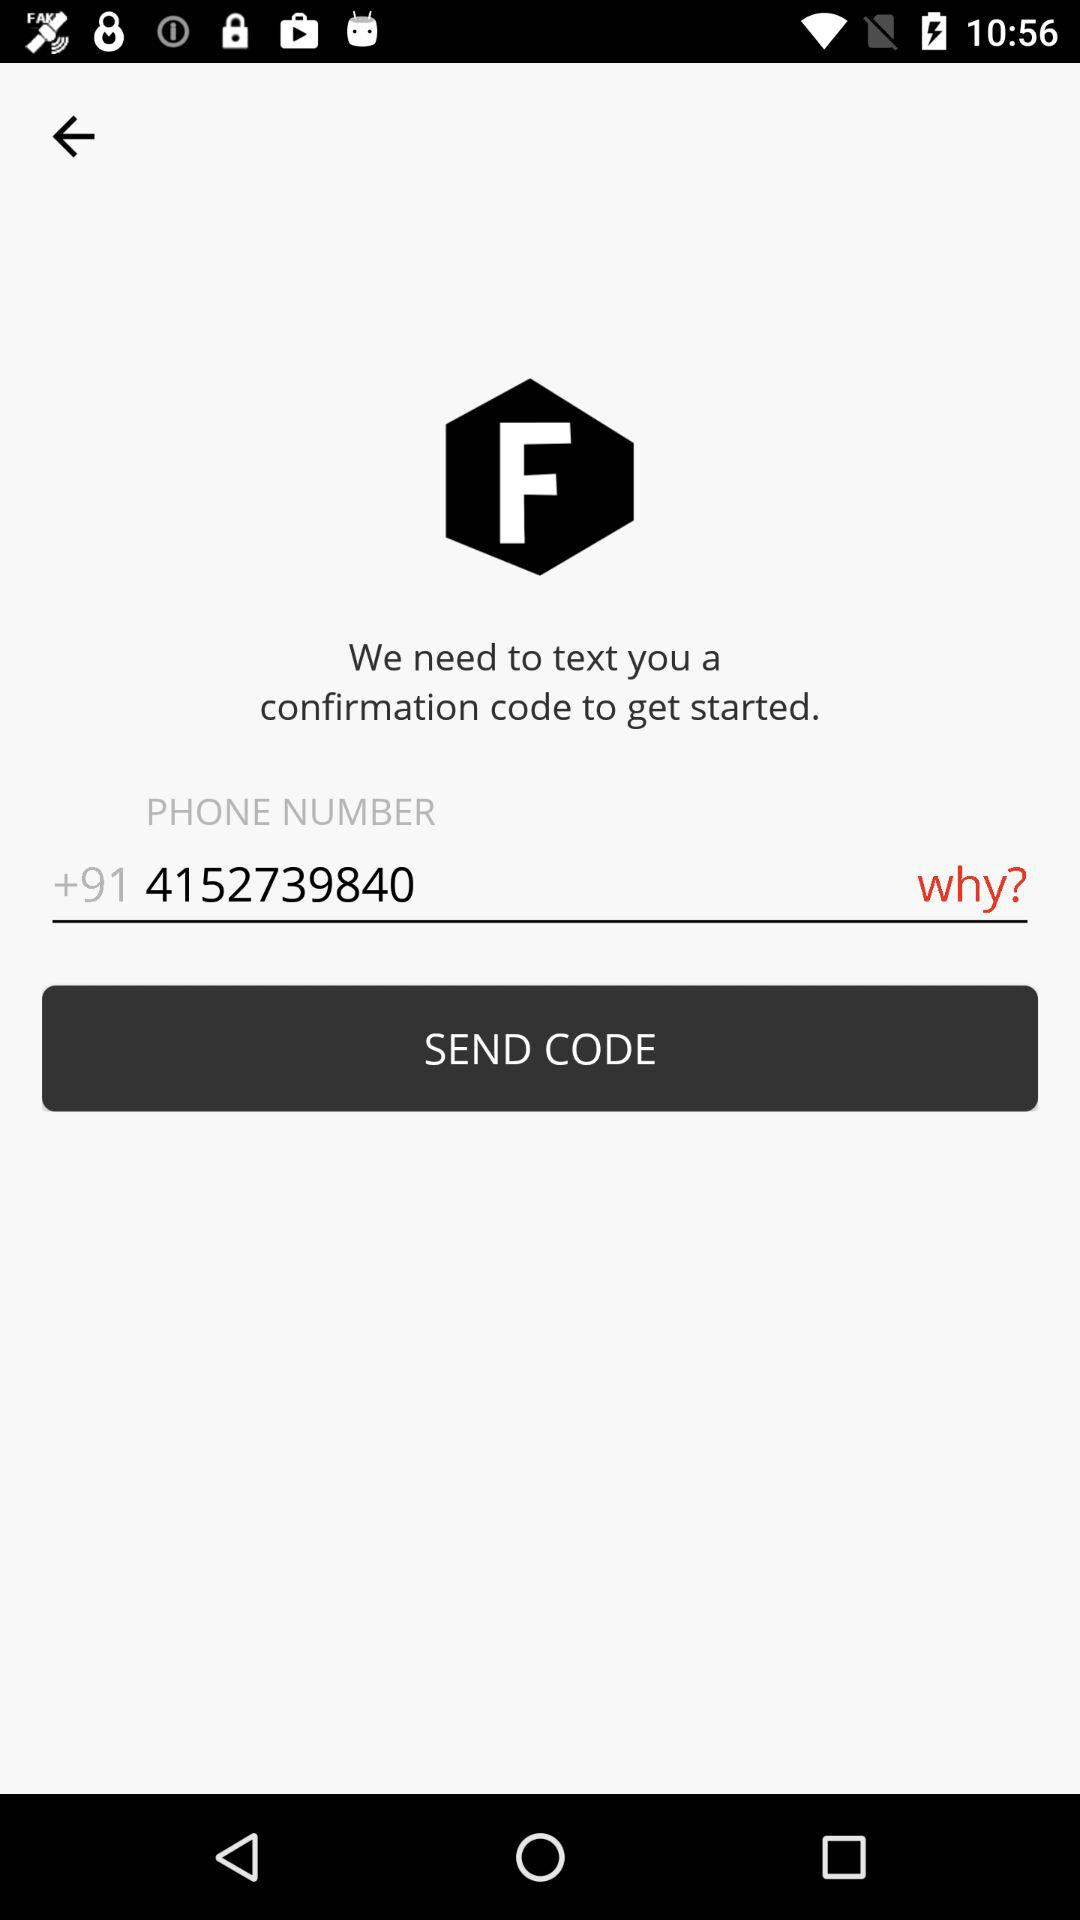How many digits are there in the phone number?
Answer the question using a single word or phrase. 10 